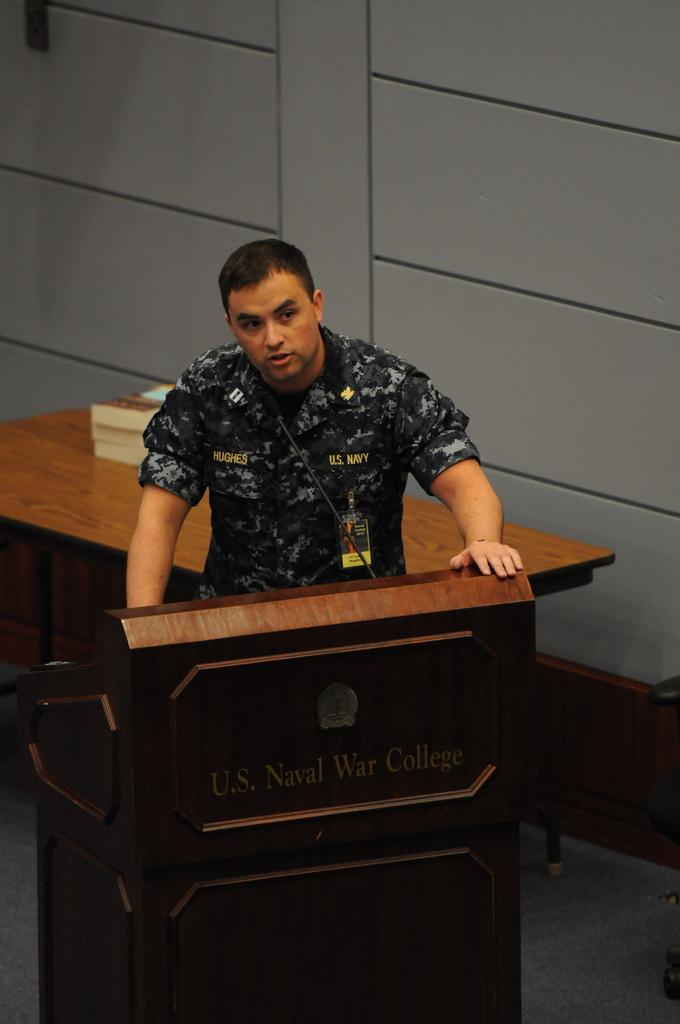What is the person in the image doing? The person is talking in front of a microphone. What might be the purpose of the microphone in the image? The microphone is likely being used to amplify the person's voice during their talk. Can you describe the setting where the person is speaking? There is a table placed behind the person, which might suggest a formal or professional setting. What type of sleet can be seen falling in the image? There is no sleet present in the image; it is an indoor setting with a person talking in front of a microphone. 